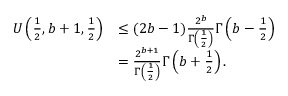<formula> <loc_0><loc_0><loc_500><loc_500>\begin{array} { r l } { U \left ( \frac { 1 } { 2 } , b + 1 , \frac { 1 } { 2 } \right ) } & { \leq ( 2 b - 1 ) \frac { 2 ^ { b } } { \Gamma \left ( \frac { 1 } { 2 } \right ) } \Gamma \left ( b - \frac { 1 } { 2 } \right ) } \\ & { = \frac { 2 ^ { b + 1 } } { \Gamma \left ( \frac { 1 } { 2 } \right ) } \Gamma \left ( b + \frac { 1 } { 2 } \right ) . } \end{array}</formula> 